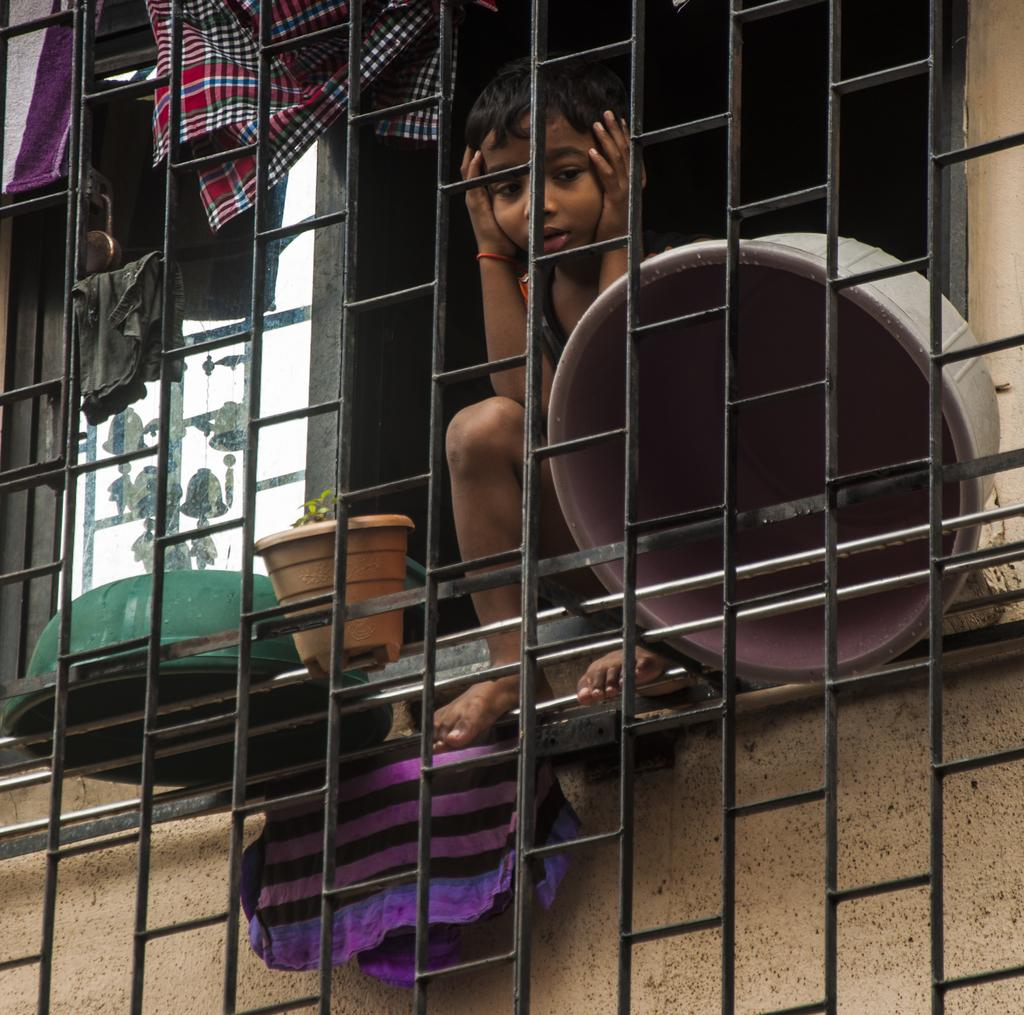What is the main object in the image? There is a grille in the image. Who or what can be seen behind the grille? A boy is visible behind the grille. What is located near the grille? There is a flower pot in the image. What might be used for hanging clothes in the image? Clothes are present in the image. What architectural feature is visible in the image? There is a window in the image. What type of surface is visible in the image? There is a wall visible in the image. What type of wax can be seen melting on the boy's head in the image? There is no wax present in the image, and the boy's head is not shown to be melting anything. 